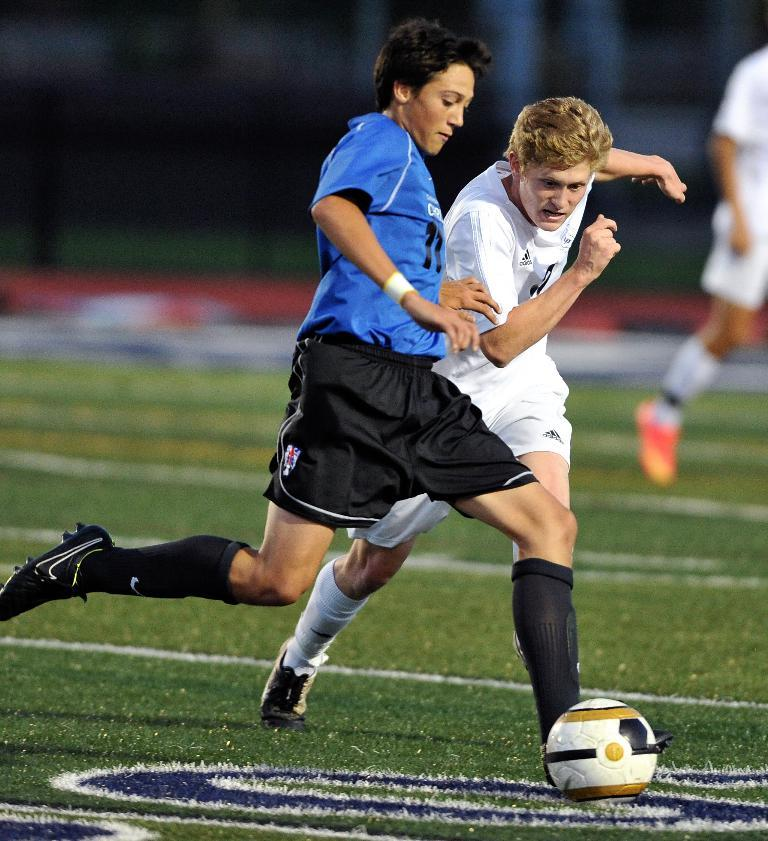What sport are the two players in the image participating in? The two players are playing football in the image. What is the color of the football field? The football field is green. What else is happening on the side of the field? There is a man running on the side of the field. What type of bone can be seen in the image? There is no bone present in the image. What time of day is it in the image? The time of day is not mentioned in the image. 